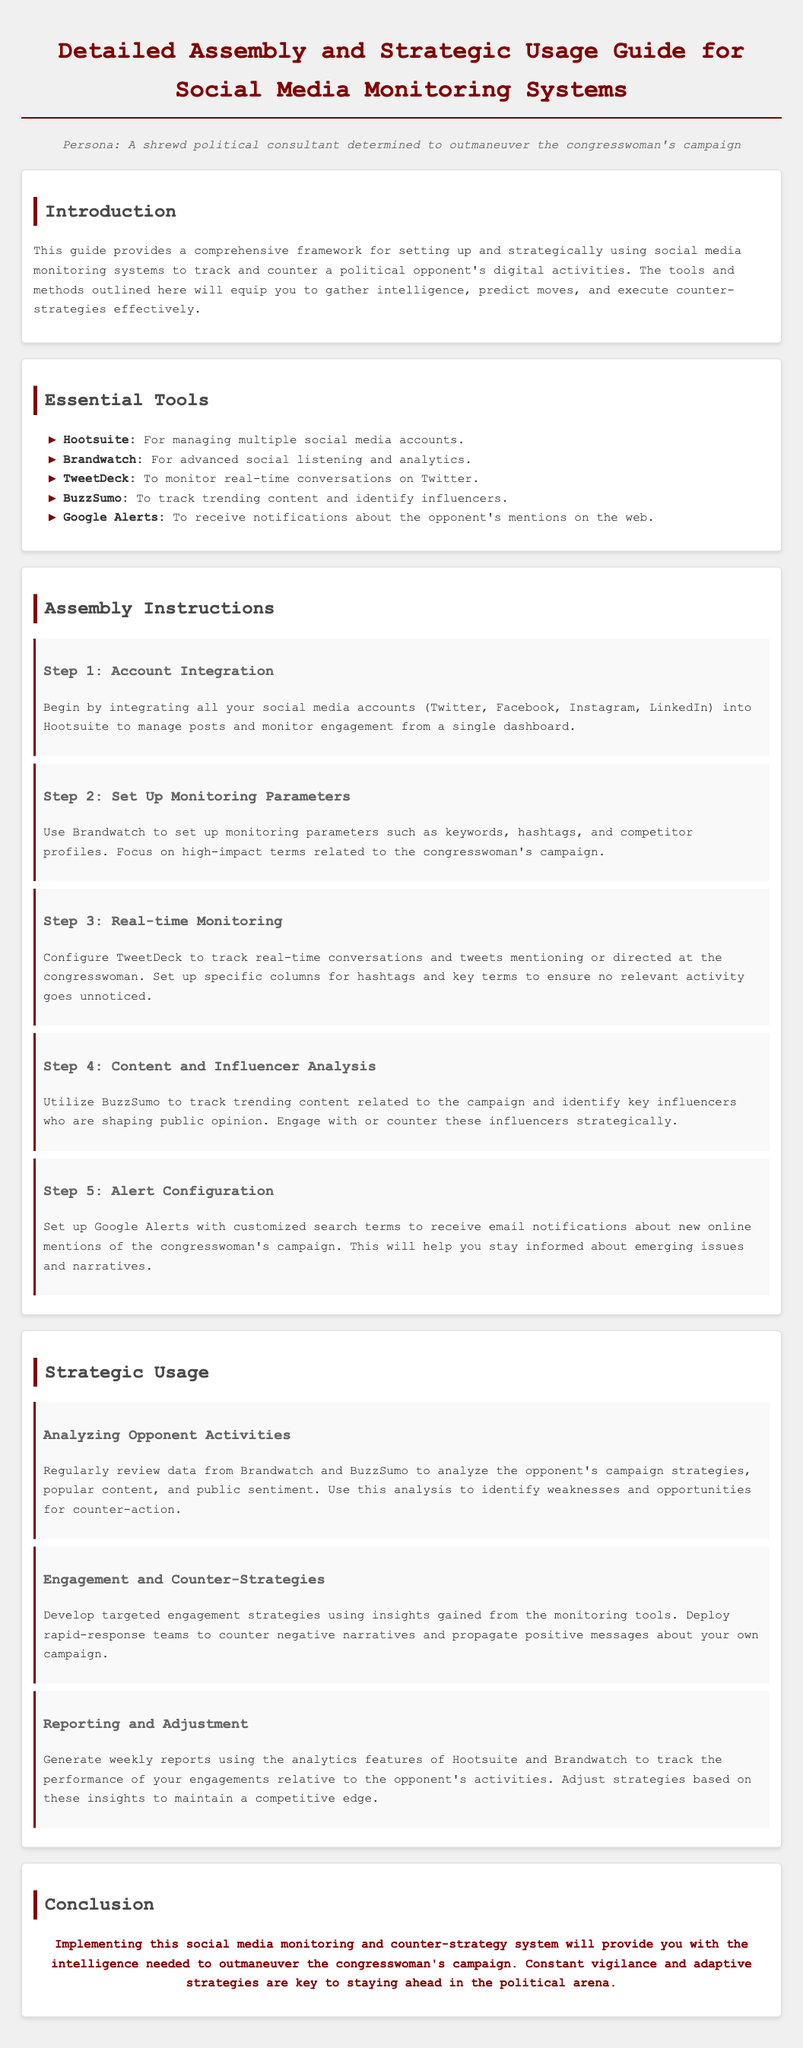what is the title of the document? The title is stated at the top of the document, in the header section.
Answer: Detailed Assembly and Strategic Usage Guide for Social Media Monitoring Systems what tool is used for managing multiple social media accounts? The tool for managing multiple social media accounts is mentioned in the Essential Tools section.
Answer: Hootsuite how many steps are there in the Assembly Instructions? The total number of steps in the Assembly Instructions can be counted from the subsections listed.
Answer: 5 which tool is recommended for advanced social listening and analytics? The recommended tool for advanced social listening and analytics is identified in the Essential Tools section.
Answer: Brandwatch what should be set up in Step 2 of the Assembly Instructions? The specific action that needs to be taken in Step 2 is described in detail in the Assembly Instructions.
Answer: Monitoring parameters what is the main goal of using the social media monitoring system? The primary objective of employing the system is outlined in the Introduction section.
Answer: Track and counter opponent's digital activities how often should reports be generated according to the Strategic Usage section? The frequency of reports is described in the Reporting and Adjustment subsection.
Answer: Weekly what is the purpose of setting up Google Alerts? The purpose of Google Alerts is detailed in Step 5 of the Assembly Instructions.
Answer: Receive notifications about the opponent's mentions which platform is used to monitor real-time conversations on Twitter? The platform for monitoring real-time conversations is identified in the Assembly Instructions.
Answer: TweetDeck 